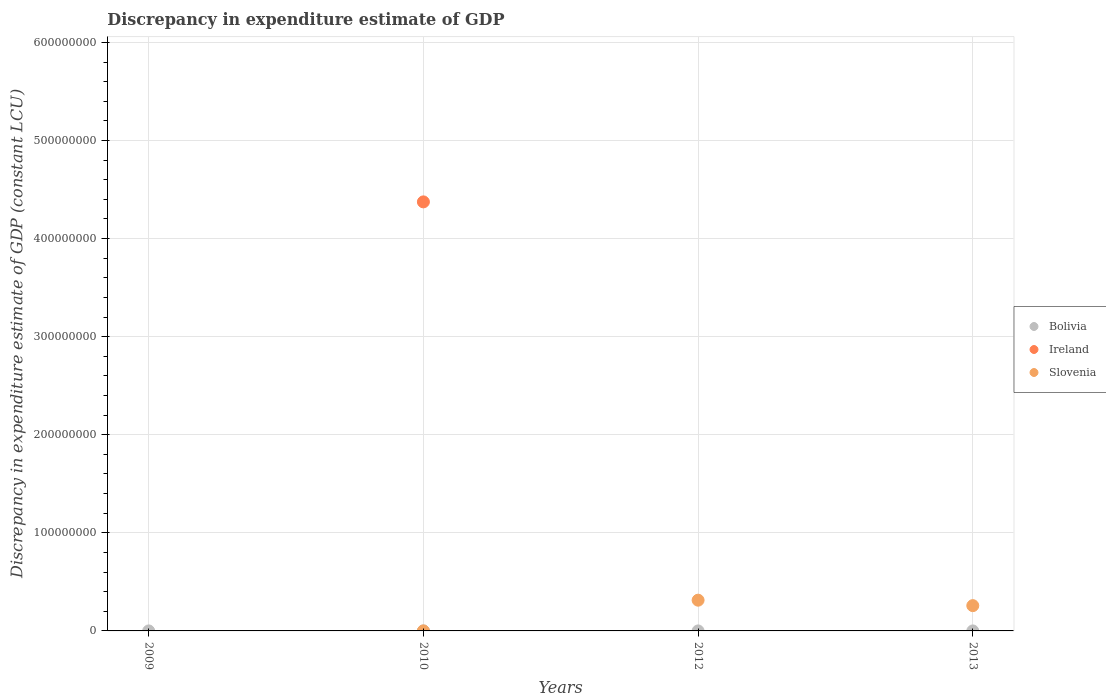How many different coloured dotlines are there?
Ensure brevity in your answer.  3. Is the number of dotlines equal to the number of legend labels?
Provide a short and direct response. No. What is the discrepancy in expenditure estimate of GDP in Slovenia in 2010?
Your answer should be compact. 10000. Across all years, what is the maximum discrepancy in expenditure estimate of GDP in Bolivia?
Offer a very short reply. 1100. Across all years, what is the minimum discrepancy in expenditure estimate of GDP in Slovenia?
Give a very brief answer. 0. In which year was the discrepancy in expenditure estimate of GDP in Slovenia maximum?
Ensure brevity in your answer.  2012. What is the total discrepancy in expenditure estimate of GDP in Slovenia in the graph?
Give a very brief answer. 5.71e+07. What is the difference between the discrepancy in expenditure estimate of GDP in Bolivia in 2009 and that in 2010?
Offer a terse response. 0. What is the difference between the discrepancy in expenditure estimate of GDP in Bolivia in 2013 and the discrepancy in expenditure estimate of GDP in Ireland in 2012?
Make the answer very short. 1100. What is the average discrepancy in expenditure estimate of GDP in Slovenia per year?
Ensure brevity in your answer.  1.43e+07. In the year 2012, what is the difference between the discrepancy in expenditure estimate of GDP in Bolivia and discrepancy in expenditure estimate of GDP in Slovenia?
Ensure brevity in your answer.  -3.13e+07. In how many years, is the discrepancy in expenditure estimate of GDP in Bolivia greater than 580000000 LCU?
Make the answer very short. 0. What is the ratio of the discrepancy in expenditure estimate of GDP in Slovenia in 2010 to that in 2012?
Offer a terse response. 0. Is the difference between the discrepancy in expenditure estimate of GDP in Bolivia in 2010 and 2012 greater than the difference between the discrepancy in expenditure estimate of GDP in Slovenia in 2010 and 2012?
Provide a short and direct response. Yes. In how many years, is the discrepancy in expenditure estimate of GDP in Bolivia greater than the average discrepancy in expenditure estimate of GDP in Bolivia taken over all years?
Offer a very short reply. 0. Is the sum of the discrepancy in expenditure estimate of GDP in Slovenia in 2012 and 2013 greater than the maximum discrepancy in expenditure estimate of GDP in Ireland across all years?
Provide a succinct answer. No. Is it the case that in every year, the sum of the discrepancy in expenditure estimate of GDP in Bolivia and discrepancy in expenditure estimate of GDP in Ireland  is greater than the discrepancy in expenditure estimate of GDP in Slovenia?
Offer a very short reply. No. Is the discrepancy in expenditure estimate of GDP in Bolivia strictly greater than the discrepancy in expenditure estimate of GDP in Ireland over the years?
Your answer should be compact. No. Is the discrepancy in expenditure estimate of GDP in Ireland strictly less than the discrepancy in expenditure estimate of GDP in Bolivia over the years?
Make the answer very short. No. How many dotlines are there?
Provide a succinct answer. 3. How many years are there in the graph?
Ensure brevity in your answer.  4. Where does the legend appear in the graph?
Give a very brief answer. Center right. How many legend labels are there?
Your response must be concise. 3. What is the title of the graph?
Provide a short and direct response. Discrepancy in expenditure estimate of GDP. What is the label or title of the X-axis?
Offer a very short reply. Years. What is the label or title of the Y-axis?
Your response must be concise. Discrepancy in expenditure estimate of GDP (constant LCU). What is the Discrepancy in expenditure estimate of GDP (constant LCU) in Bolivia in 2009?
Offer a terse response. 1100. What is the Discrepancy in expenditure estimate of GDP (constant LCU) in Ireland in 2009?
Give a very brief answer. 0. What is the Discrepancy in expenditure estimate of GDP (constant LCU) in Bolivia in 2010?
Give a very brief answer. 1100. What is the Discrepancy in expenditure estimate of GDP (constant LCU) in Ireland in 2010?
Offer a terse response. 4.37e+08. What is the Discrepancy in expenditure estimate of GDP (constant LCU) of Bolivia in 2012?
Ensure brevity in your answer.  1100. What is the Discrepancy in expenditure estimate of GDP (constant LCU) of Ireland in 2012?
Give a very brief answer. 0. What is the Discrepancy in expenditure estimate of GDP (constant LCU) in Slovenia in 2012?
Provide a short and direct response. 3.13e+07. What is the Discrepancy in expenditure estimate of GDP (constant LCU) of Bolivia in 2013?
Ensure brevity in your answer.  1100. What is the Discrepancy in expenditure estimate of GDP (constant LCU) of Ireland in 2013?
Keep it short and to the point. 0. What is the Discrepancy in expenditure estimate of GDP (constant LCU) in Slovenia in 2013?
Your response must be concise. 2.58e+07. Across all years, what is the maximum Discrepancy in expenditure estimate of GDP (constant LCU) in Bolivia?
Keep it short and to the point. 1100. Across all years, what is the maximum Discrepancy in expenditure estimate of GDP (constant LCU) of Ireland?
Provide a succinct answer. 4.37e+08. Across all years, what is the maximum Discrepancy in expenditure estimate of GDP (constant LCU) in Slovenia?
Offer a terse response. 3.13e+07. Across all years, what is the minimum Discrepancy in expenditure estimate of GDP (constant LCU) in Bolivia?
Give a very brief answer. 1100. Across all years, what is the minimum Discrepancy in expenditure estimate of GDP (constant LCU) in Ireland?
Provide a succinct answer. 0. What is the total Discrepancy in expenditure estimate of GDP (constant LCU) in Bolivia in the graph?
Keep it short and to the point. 4400. What is the total Discrepancy in expenditure estimate of GDP (constant LCU) of Ireland in the graph?
Offer a terse response. 4.37e+08. What is the total Discrepancy in expenditure estimate of GDP (constant LCU) of Slovenia in the graph?
Provide a short and direct response. 5.71e+07. What is the difference between the Discrepancy in expenditure estimate of GDP (constant LCU) of Bolivia in 2009 and that in 2013?
Offer a terse response. 0. What is the difference between the Discrepancy in expenditure estimate of GDP (constant LCU) of Slovenia in 2010 and that in 2012?
Make the answer very short. -3.13e+07. What is the difference between the Discrepancy in expenditure estimate of GDP (constant LCU) in Slovenia in 2010 and that in 2013?
Offer a terse response. -2.58e+07. What is the difference between the Discrepancy in expenditure estimate of GDP (constant LCU) in Bolivia in 2012 and that in 2013?
Your response must be concise. 0. What is the difference between the Discrepancy in expenditure estimate of GDP (constant LCU) of Slovenia in 2012 and that in 2013?
Your answer should be compact. 5.56e+06. What is the difference between the Discrepancy in expenditure estimate of GDP (constant LCU) in Bolivia in 2009 and the Discrepancy in expenditure estimate of GDP (constant LCU) in Ireland in 2010?
Your answer should be compact. -4.37e+08. What is the difference between the Discrepancy in expenditure estimate of GDP (constant LCU) of Bolivia in 2009 and the Discrepancy in expenditure estimate of GDP (constant LCU) of Slovenia in 2010?
Your answer should be very brief. -8900. What is the difference between the Discrepancy in expenditure estimate of GDP (constant LCU) of Bolivia in 2009 and the Discrepancy in expenditure estimate of GDP (constant LCU) of Slovenia in 2012?
Offer a very short reply. -3.13e+07. What is the difference between the Discrepancy in expenditure estimate of GDP (constant LCU) of Bolivia in 2009 and the Discrepancy in expenditure estimate of GDP (constant LCU) of Slovenia in 2013?
Your answer should be very brief. -2.58e+07. What is the difference between the Discrepancy in expenditure estimate of GDP (constant LCU) in Bolivia in 2010 and the Discrepancy in expenditure estimate of GDP (constant LCU) in Slovenia in 2012?
Keep it short and to the point. -3.13e+07. What is the difference between the Discrepancy in expenditure estimate of GDP (constant LCU) of Ireland in 2010 and the Discrepancy in expenditure estimate of GDP (constant LCU) of Slovenia in 2012?
Ensure brevity in your answer.  4.06e+08. What is the difference between the Discrepancy in expenditure estimate of GDP (constant LCU) of Bolivia in 2010 and the Discrepancy in expenditure estimate of GDP (constant LCU) of Slovenia in 2013?
Offer a very short reply. -2.58e+07. What is the difference between the Discrepancy in expenditure estimate of GDP (constant LCU) of Ireland in 2010 and the Discrepancy in expenditure estimate of GDP (constant LCU) of Slovenia in 2013?
Give a very brief answer. 4.12e+08. What is the difference between the Discrepancy in expenditure estimate of GDP (constant LCU) in Bolivia in 2012 and the Discrepancy in expenditure estimate of GDP (constant LCU) in Slovenia in 2013?
Ensure brevity in your answer.  -2.58e+07. What is the average Discrepancy in expenditure estimate of GDP (constant LCU) in Bolivia per year?
Provide a short and direct response. 1100. What is the average Discrepancy in expenditure estimate of GDP (constant LCU) in Ireland per year?
Provide a short and direct response. 1.09e+08. What is the average Discrepancy in expenditure estimate of GDP (constant LCU) of Slovenia per year?
Give a very brief answer. 1.43e+07. In the year 2010, what is the difference between the Discrepancy in expenditure estimate of GDP (constant LCU) in Bolivia and Discrepancy in expenditure estimate of GDP (constant LCU) in Ireland?
Ensure brevity in your answer.  -4.37e+08. In the year 2010, what is the difference between the Discrepancy in expenditure estimate of GDP (constant LCU) in Bolivia and Discrepancy in expenditure estimate of GDP (constant LCU) in Slovenia?
Your response must be concise. -8900. In the year 2010, what is the difference between the Discrepancy in expenditure estimate of GDP (constant LCU) in Ireland and Discrepancy in expenditure estimate of GDP (constant LCU) in Slovenia?
Give a very brief answer. 4.37e+08. In the year 2012, what is the difference between the Discrepancy in expenditure estimate of GDP (constant LCU) of Bolivia and Discrepancy in expenditure estimate of GDP (constant LCU) of Slovenia?
Your answer should be compact. -3.13e+07. In the year 2013, what is the difference between the Discrepancy in expenditure estimate of GDP (constant LCU) in Bolivia and Discrepancy in expenditure estimate of GDP (constant LCU) in Slovenia?
Provide a succinct answer. -2.58e+07. What is the ratio of the Discrepancy in expenditure estimate of GDP (constant LCU) in Bolivia in 2009 to that in 2012?
Keep it short and to the point. 1. What is the ratio of the Discrepancy in expenditure estimate of GDP (constant LCU) in Slovenia in 2010 to that in 2012?
Ensure brevity in your answer.  0. What is the ratio of the Discrepancy in expenditure estimate of GDP (constant LCU) of Bolivia in 2010 to that in 2013?
Ensure brevity in your answer.  1. What is the ratio of the Discrepancy in expenditure estimate of GDP (constant LCU) in Slovenia in 2010 to that in 2013?
Your response must be concise. 0. What is the ratio of the Discrepancy in expenditure estimate of GDP (constant LCU) in Bolivia in 2012 to that in 2013?
Provide a short and direct response. 1. What is the ratio of the Discrepancy in expenditure estimate of GDP (constant LCU) of Slovenia in 2012 to that in 2013?
Offer a very short reply. 1.22. What is the difference between the highest and the second highest Discrepancy in expenditure estimate of GDP (constant LCU) in Bolivia?
Your answer should be compact. 0. What is the difference between the highest and the second highest Discrepancy in expenditure estimate of GDP (constant LCU) of Slovenia?
Keep it short and to the point. 5.56e+06. What is the difference between the highest and the lowest Discrepancy in expenditure estimate of GDP (constant LCU) in Ireland?
Offer a very short reply. 4.37e+08. What is the difference between the highest and the lowest Discrepancy in expenditure estimate of GDP (constant LCU) of Slovenia?
Provide a succinct answer. 3.13e+07. 